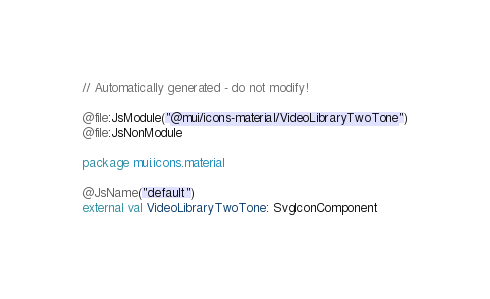<code> <loc_0><loc_0><loc_500><loc_500><_Kotlin_>// Automatically generated - do not modify!

@file:JsModule("@mui/icons-material/VideoLibraryTwoTone")
@file:JsNonModule

package mui.icons.material

@JsName("default")
external val VideoLibraryTwoTone: SvgIconComponent
</code> 